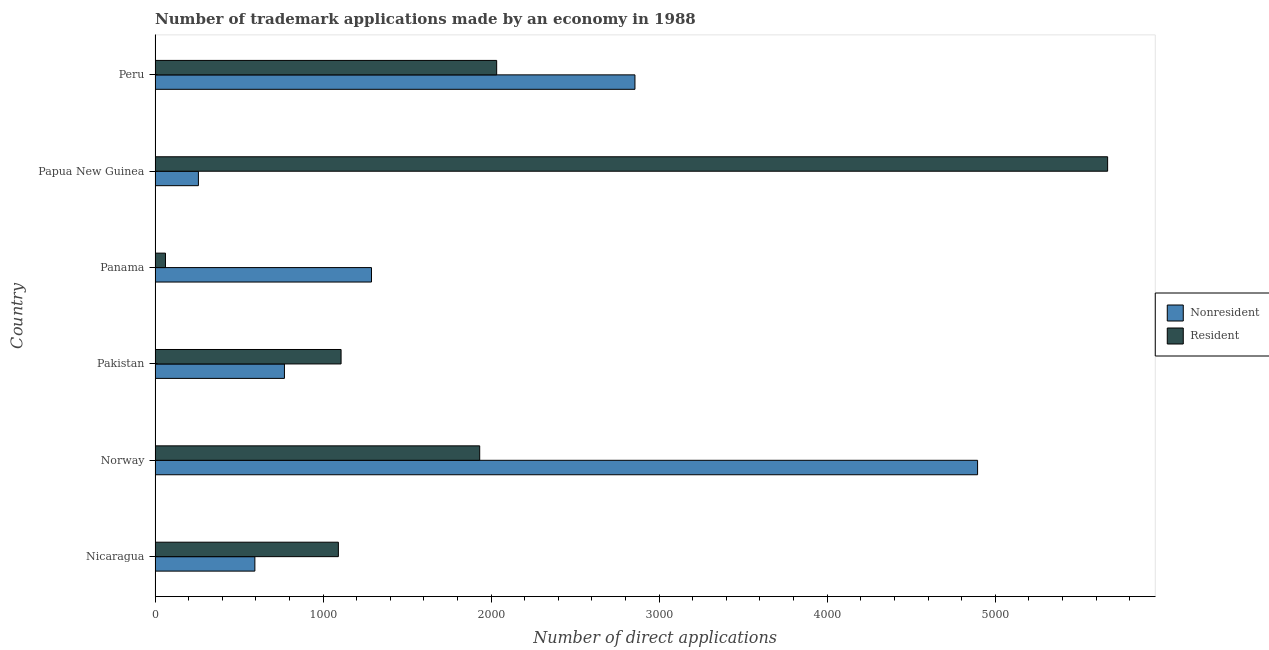How many different coloured bars are there?
Make the answer very short. 2. How many groups of bars are there?
Your response must be concise. 6. Are the number of bars per tick equal to the number of legend labels?
Provide a succinct answer. Yes. How many bars are there on the 2nd tick from the top?
Give a very brief answer. 2. In how many cases, is the number of bars for a given country not equal to the number of legend labels?
Offer a terse response. 0. What is the number of trademark applications made by non residents in Nicaragua?
Keep it short and to the point. 594. Across all countries, what is the maximum number of trademark applications made by non residents?
Your answer should be compact. 4895. Across all countries, what is the minimum number of trademark applications made by residents?
Your answer should be compact. 62. In which country was the number of trademark applications made by non residents minimum?
Your response must be concise. Papua New Guinea. What is the total number of trademark applications made by non residents in the graph?
Offer a very short reply. 1.07e+04. What is the difference between the number of trademark applications made by non residents in Nicaragua and that in Panama?
Your answer should be very brief. -694. What is the difference between the number of trademark applications made by non residents in Panama and the number of trademark applications made by residents in Nicaragua?
Ensure brevity in your answer.  197. What is the average number of trademark applications made by non residents per country?
Make the answer very short. 1776.83. What is the difference between the number of trademark applications made by non residents and number of trademark applications made by residents in Peru?
Your answer should be compact. 823. What is the ratio of the number of trademark applications made by residents in Pakistan to that in Papua New Guinea?
Ensure brevity in your answer.  0.2. Is the number of trademark applications made by non residents in Nicaragua less than that in Pakistan?
Your answer should be compact. Yes. Is the difference between the number of trademark applications made by residents in Nicaragua and Panama greater than the difference between the number of trademark applications made by non residents in Nicaragua and Panama?
Make the answer very short. Yes. What is the difference between the highest and the second highest number of trademark applications made by non residents?
Offer a very short reply. 2039. What is the difference between the highest and the lowest number of trademark applications made by residents?
Your response must be concise. 5607. Is the sum of the number of trademark applications made by residents in Nicaragua and Norway greater than the maximum number of trademark applications made by non residents across all countries?
Give a very brief answer. No. What does the 2nd bar from the top in Nicaragua represents?
Provide a succinct answer. Nonresident. What does the 2nd bar from the bottom in Norway represents?
Give a very brief answer. Resident. How many bars are there?
Ensure brevity in your answer.  12. Are all the bars in the graph horizontal?
Keep it short and to the point. Yes. Does the graph contain any zero values?
Offer a terse response. No. How many legend labels are there?
Your response must be concise. 2. How are the legend labels stacked?
Provide a short and direct response. Vertical. What is the title of the graph?
Your answer should be very brief. Number of trademark applications made by an economy in 1988. Does "Adolescent fertility rate" appear as one of the legend labels in the graph?
Make the answer very short. No. What is the label or title of the X-axis?
Your answer should be very brief. Number of direct applications. What is the label or title of the Y-axis?
Your answer should be very brief. Country. What is the Number of direct applications in Nonresident in Nicaragua?
Offer a terse response. 594. What is the Number of direct applications of Resident in Nicaragua?
Provide a short and direct response. 1091. What is the Number of direct applications of Nonresident in Norway?
Make the answer very short. 4895. What is the Number of direct applications in Resident in Norway?
Provide a short and direct response. 1932. What is the Number of direct applications of Nonresident in Pakistan?
Offer a terse response. 770. What is the Number of direct applications of Resident in Pakistan?
Make the answer very short. 1107. What is the Number of direct applications in Nonresident in Panama?
Ensure brevity in your answer.  1288. What is the Number of direct applications in Resident in Panama?
Give a very brief answer. 62. What is the Number of direct applications of Nonresident in Papua New Guinea?
Your answer should be very brief. 258. What is the Number of direct applications in Resident in Papua New Guinea?
Offer a very short reply. 5669. What is the Number of direct applications of Nonresident in Peru?
Your answer should be very brief. 2856. What is the Number of direct applications in Resident in Peru?
Give a very brief answer. 2033. Across all countries, what is the maximum Number of direct applications of Nonresident?
Provide a succinct answer. 4895. Across all countries, what is the maximum Number of direct applications in Resident?
Offer a very short reply. 5669. Across all countries, what is the minimum Number of direct applications in Nonresident?
Make the answer very short. 258. What is the total Number of direct applications in Nonresident in the graph?
Make the answer very short. 1.07e+04. What is the total Number of direct applications of Resident in the graph?
Offer a very short reply. 1.19e+04. What is the difference between the Number of direct applications of Nonresident in Nicaragua and that in Norway?
Your answer should be compact. -4301. What is the difference between the Number of direct applications in Resident in Nicaragua and that in Norway?
Offer a terse response. -841. What is the difference between the Number of direct applications of Nonresident in Nicaragua and that in Pakistan?
Your response must be concise. -176. What is the difference between the Number of direct applications of Nonresident in Nicaragua and that in Panama?
Provide a short and direct response. -694. What is the difference between the Number of direct applications in Resident in Nicaragua and that in Panama?
Give a very brief answer. 1029. What is the difference between the Number of direct applications of Nonresident in Nicaragua and that in Papua New Guinea?
Offer a very short reply. 336. What is the difference between the Number of direct applications in Resident in Nicaragua and that in Papua New Guinea?
Your response must be concise. -4578. What is the difference between the Number of direct applications in Nonresident in Nicaragua and that in Peru?
Keep it short and to the point. -2262. What is the difference between the Number of direct applications of Resident in Nicaragua and that in Peru?
Offer a very short reply. -942. What is the difference between the Number of direct applications in Nonresident in Norway and that in Pakistan?
Provide a short and direct response. 4125. What is the difference between the Number of direct applications of Resident in Norway and that in Pakistan?
Your answer should be compact. 825. What is the difference between the Number of direct applications of Nonresident in Norway and that in Panama?
Keep it short and to the point. 3607. What is the difference between the Number of direct applications of Resident in Norway and that in Panama?
Keep it short and to the point. 1870. What is the difference between the Number of direct applications of Nonresident in Norway and that in Papua New Guinea?
Ensure brevity in your answer.  4637. What is the difference between the Number of direct applications of Resident in Norway and that in Papua New Guinea?
Keep it short and to the point. -3737. What is the difference between the Number of direct applications of Nonresident in Norway and that in Peru?
Your answer should be compact. 2039. What is the difference between the Number of direct applications of Resident in Norway and that in Peru?
Ensure brevity in your answer.  -101. What is the difference between the Number of direct applications of Nonresident in Pakistan and that in Panama?
Keep it short and to the point. -518. What is the difference between the Number of direct applications in Resident in Pakistan and that in Panama?
Make the answer very short. 1045. What is the difference between the Number of direct applications of Nonresident in Pakistan and that in Papua New Guinea?
Your answer should be compact. 512. What is the difference between the Number of direct applications of Resident in Pakistan and that in Papua New Guinea?
Offer a very short reply. -4562. What is the difference between the Number of direct applications of Nonresident in Pakistan and that in Peru?
Offer a very short reply. -2086. What is the difference between the Number of direct applications of Resident in Pakistan and that in Peru?
Your answer should be very brief. -926. What is the difference between the Number of direct applications in Nonresident in Panama and that in Papua New Guinea?
Provide a succinct answer. 1030. What is the difference between the Number of direct applications in Resident in Panama and that in Papua New Guinea?
Make the answer very short. -5607. What is the difference between the Number of direct applications in Nonresident in Panama and that in Peru?
Give a very brief answer. -1568. What is the difference between the Number of direct applications of Resident in Panama and that in Peru?
Keep it short and to the point. -1971. What is the difference between the Number of direct applications in Nonresident in Papua New Guinea and that in Peru?
Make the answer very short. -2598. What is the difference between the Number of direct applications in Resident in Papua New Guinea and that in Peru?
Provide a succinct answer. 3636. What is the difference between the Number of direct applications of Nonresident in Nicaragua and the Number of direct applications of Resident in Norway?
Offer a very short reply. -1338. What is the difference between the Number of direct applications of Nonresident in Nicaragua and the Number of direct applications of Resident in Pakistan?
Make the answer very short. -513. What is the difference between the Number of direct applications in Nonresident in Nicaragua and the Number of direct applications in Resident in Panama?
Your answer should be compact. 532. What is the difference between the Number of direct applications of Nonresident in Nicaragua and the Number of direct applications of Resident in Papua New Guinea?
Your answer should be compact. -5075. What is the difference between the Number of direct applications in Nonresident in Nicaragua and the Number of direct applications in Resident in Peru?
Provide a succinct answer. -1439. What is the difference between the Number of direct applications in Nonresident in Norway and the Number of direct applications in Resident in Pakistan?
Offer a terse response. 3788. What is the difference between the Number of direct applications in Nonresident in Norway and the Number of direct applications in Resident in Panama?
Provide a short and direct response. 4833. What is the difference between the Number of direct applications in Nonresident in Norway and the Number of direct applications in Resident in Papua New Guinea?
Give a very brief answer. -774. What is the difference between the Number of direct applications in Nonresident in Norway and the Number of direct applications in Resident in Peru?
Give a very brief answer. 2862. What is the difference between the Number of direct applications in Nonresident in Pakistan and the Number of direct applications in Resident in Panama?
Your answer should be very brief. 708. What is the difference between the Number of direct applications of Nonresident in Pakistan and the Number of direct applications of Resident in Papua New Guinea?
Keep it short and to the point. -4899. What is the difference between the Number of direct applications in Nonresident in Pakistan and the Number of direct applications in Resident in Peru?
Make the answer very short. -1263. What is the difference between the Number of direct applications of Nonresident in Panama and the Number of direct applications of Resident in Papua New Guinea?
Ensure brevity in your answer.  -4381. What is the difference between the Number of direct applications of Nonresident in Panama and the Number of direct applications of Resident in Peru?
Your answer should be compact. -745. What is the difference between the Number of direct applications of Nonresident in Papua New Guinea and the Number of direct applications of Resident in Peru?
Offer a very short reply. -1775. What is the average Number of direct applications of Nonresident per country?
Your response must be concise. 1776.83. What is the average Number of direct applications of Resident per country?
Your answer should be compact. 1982.33. What is the difference between the Number of direct applications of Nonresident and Number of direct applications of Resident in Nicaragua?
Offer a very short reply. -497. What is the difference between the Number of direct applications of Nonresident and Number of direct applications of Resident in Norway?
Provide a short and direct response. 2963. What is the difference between the Number of direct applications of Nonresident and Number of direct applications of Resident in Pakistan?
Keep it short and to the point. -337. What is the difference between the Number of direct applications in Nonresident and Number of direct applications in Resident in Panama?
Offer a very short reply. 1226. What is the difference between the Number of direct applications of Nonresident and Number of direct applications of Resident in Papua New Guinea?
Ensure brevity in your answer.  -5411. What is the difference between the Number of direct applications of Nonresident and Number of direct applications of Resident in Peru?
Your answer should be compact. 823. What is the ratio of the Number of direct applications in Nonresident in Nicaragua to that in Norway?
Offer a terse response. 0.12. What is the ratio of the Number of direct applications of Resident in Nicaragua to that in Norway?
Offer a very short reply. 0.56. What is the ratio of the Number of direct applications in Nonresident in Nicaragua to that in Pakistan?
Give a very brief answer. 0.77. What is the ratio of the Number of direct applications in Resident in Nicaragua to that in Pakistan?
Give a very brief answer. 0.99. What is the ratio of the Number of direct applications of Nonresident in Nicaragua to that in Panama?
Your answer should be very brief. 0.46. What is the ratio of the Number of direct applications in Resident in Nicaragua to that in Panama?
Provide a succinct answer. 17.6. What is the ratio of the Number of direct applications of Nonresident in Nicaragua to that in Papua New Guinea?
Provide a succinct answer. 2.3. What is the ratio of the Number of direct applications of Resident in Nicaragua to that in Papua New Guinea?
Offer a very short reply. 0.19. What is the ratio of the Number of direct applications in Nonresident in Nicaragua to that in Peru?
Provide a short and direct response. 0.21. What is the ratio of the Number of direct applications in Resident in Nicaragua to that in Peru?
Keep it short and to the point. 0.54. What is the ratio of the Number of direct applications in Nonresident in Norway to that in Pakistan?
Provide a short and direct response. 6.36. What is the ratio of the Number of direct applications in Resident in Norway to that in Pakistan?
Give a very brief answer. 1.75. What is the ratio of the Number of direct applications in Nonresident in Norway to that in Panama?
Provide a short and direct response. 3.8. What is the ratio of the Number of direct applications in Resident in Norway to that in Panama?
Give a very brief answer. 31.16. What is the ratio of the Number of direct applications of Nonresident in Norway to that in Papua New Guinea?
Keep it short and to the point. 18.97. What is the ratio of the Number of direct applications in Resident in Norway to that in Papua New Guinea?
Provide a succinct answer. 0.34. What is the ratio of the Number of direct applications of Nonresident in Norway to that in Peru?
Provide a short and direct response. 1.71. What is the ratio of the Number of direct applications of Resident in Norway to that in Peru?
Your answer should be compact. 0.95. What is the ratio of the Number of direct applications in Nonresident in Pakistan to that in Panama?
Ensure brevity in your answer.  0.6. What is the ratio of the Number of direct applications of Resident in Pakistan to that in Panama?
Your answer should be very brief. 17.85. What is the ratio of the Number of direct applications of Nonresident in Pakistan to that in Papua New Guinea?
Provide a short and direct response. 2.98. What is the ratio of the Number of direct applications of Resident in Pakistan to that in Papua New Guinea?
Your answer should be compact. 0.2. What is the ratio of the Number of direct applications in Nonresident in Pakistan to that in Peru?
Your answer should be very brief. 0.27. What is the ratio of the Number of direct applications of Resident in Pakistan to that in Peru?
Offer a very short reply. 0.54. What is the ratio of the Number of direct applications in Nonresident in Panama to that in Papua New Guinea?
Ensure brevity in your answer.  4.99. What is the ratio of the Number of direct applications of Resident in Panama to that in Papua New Guinea?
Keep it short and to the point. 0.01. What is the ratio of the Number of direct applications in Nonresident in Panama to that in Peru?
Your response must be concise. 0.45. What is the ratio of the Number of direct applications in Resident in Panama to that in Peru?
Provide a succinct answer. 0.03. What is the ratio of the Number of direct applications of Nonresident in Papua New Guinea to that in Peru?
Make the answer very short. 0.09. What is the ratio of the Number of direct applications of Resident in Papua New Guinea to that in Peru?
Offer a very short reply. 2.79. What is the difference between the highest and the second highest Number of direct applications in Nonresident?
Make the answer very short. 2039. What is the difference between the highest and the second highest Number of direct applications in Resident?
Offer a terse response. 3636. What is the difference between the highest and the lowest Number of direct applications of Nonresident?
Your answer should be compact. 4637. What is the difference between the highest and the lowest Number of direct applications in Resident?
Provide a succinct answer. 5607. 